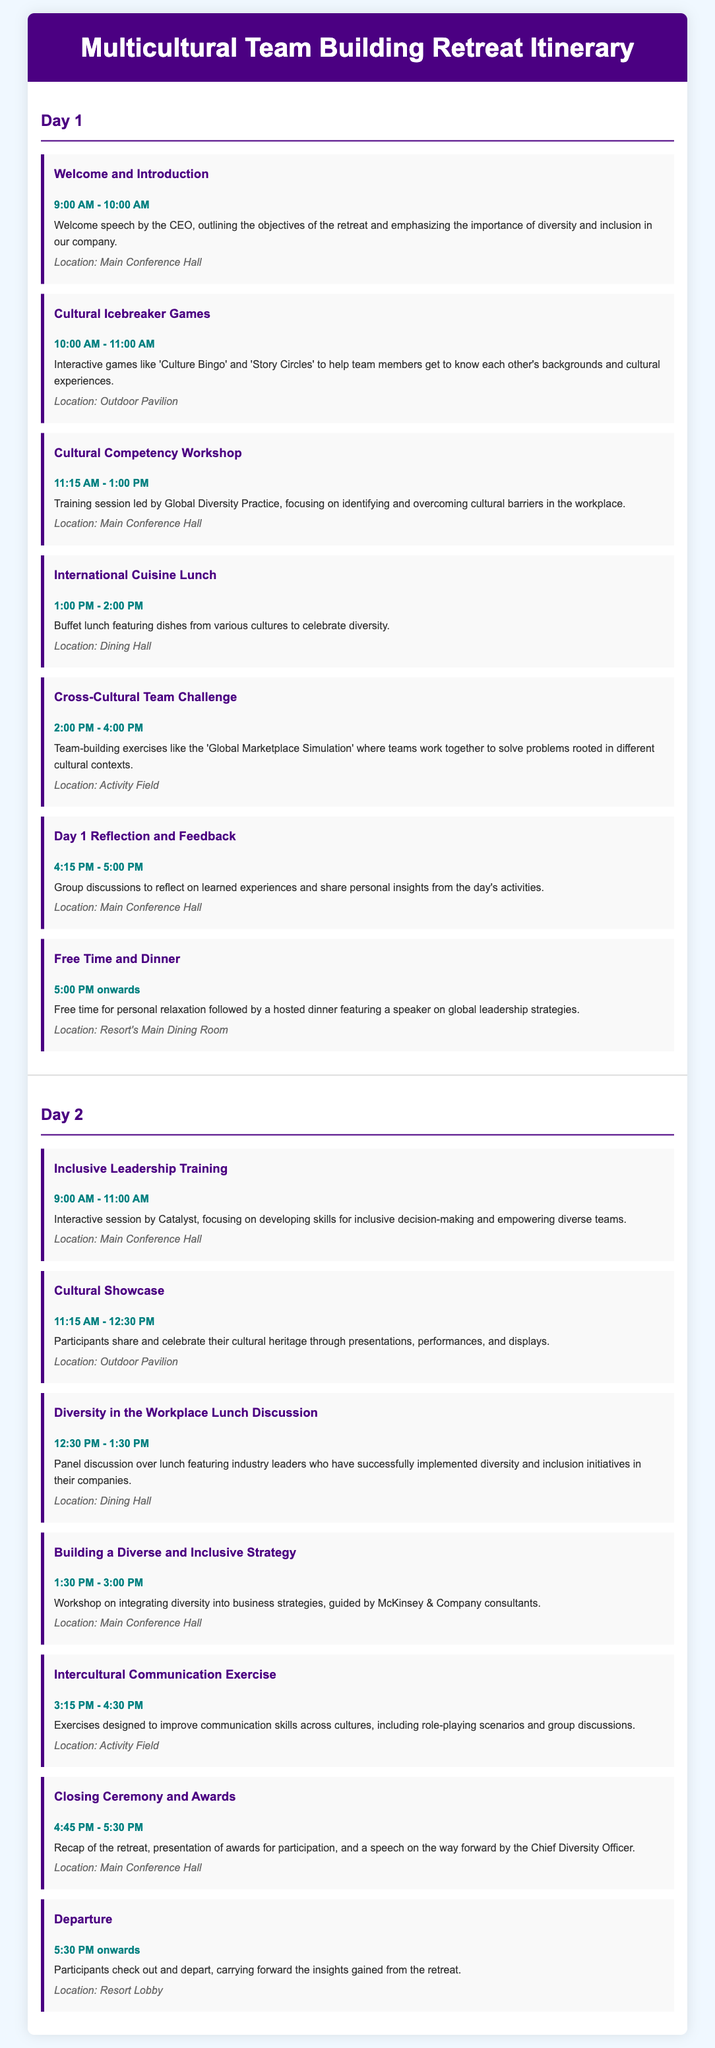what time does the welcome speech start? The welcome speech by the CEO starts at 9:00 AM.
Answer: 9:00 AM how long is the Cultural Competency Workshop? The Cultural Competency Workshop lasts from 11:15 AM to 1:00 PM, which is a total of 1 hour and 45 minutes.
Answer: 1 hour and 45 minutes who leads the Inclusive Leadership Training? The Inclusive Leadership Training is conducted by Catalyst.
Answer: Catalyst what is the location for the International Cuisine Lunch? The location for the International Cuisine Lunch is the Dining Hall.
Answer: Dining Hall how are team members introduced to each other's cultures? Team members are introduced through interactive games like 'Culture Bingo' and 'Story Circles'.
Answer: Interactive games what type of activity is the Cross-Cultural Team Challenge? The Cross-Cultural Team Challenge consists of team-building exercises like the 'Global Marketplace Simulation'.
Answer: Team-building exercises what is featured during the Cultural Showcase? During the Cultural Showcase, participants share and celebrate their cultural heritage through presentations, performances, and displays.
Answer: Presentations, performances, and displays who gives the closing speech? The closing speech is given by the Chief Diversity Officer.
Answer: Chief Diversity Officer when does the retreat conclude? The retreat concludes at 5:30 PM.
Answer: 5:30 PM 